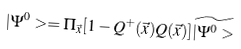Convert formula to latex. <formula><loc_0><loc_0><loc_500><loc_500>| \Psi ^ { 0 } > = { \Pi } _ { \vec { x } } [ 1 - Q ^ { + } ( \vec { x } ) Q ( \vec { x } ) ] \widetilde { | \Psi ^ { 0 } > }</formula> 